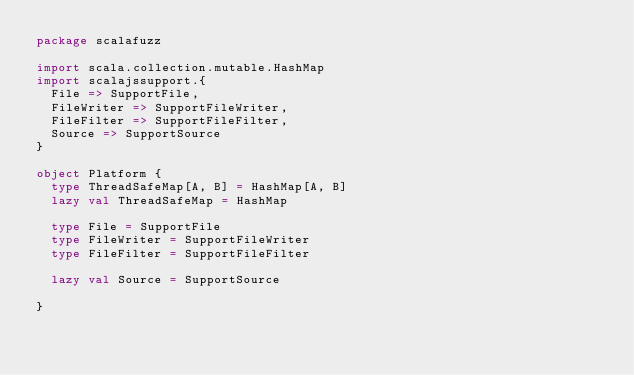Convert code to text. <code><loc_0><loc_0><loc_500><loc_500><_Scala_>package scalafuzz

import scala.collection.mutable.HashMap
import scalajssupport.{
  File => SupportFile,
  FileWriter => SupportFileWriter,
  FileFilter => SupportFileFilter,
  Source => SupportSource
}

object Platform {
  type ThreadSafeMap[A, B] = HashMap[A, B]
  lazy val ThreadSafeMap = HashMap

  type File = SupportFile
  type FileWriter = SupportFileWriter
  type FileFilter = SupportFileFilter

  lazy val Source = SupportSource

}
</code> 